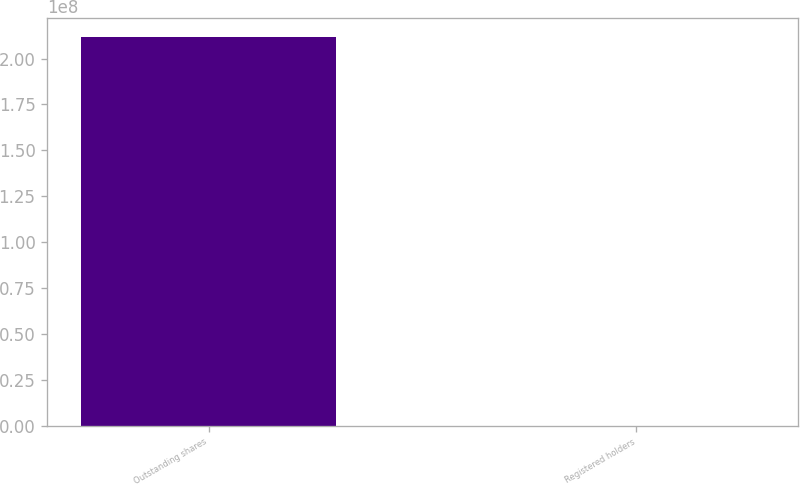Convert chart. <chart><loc_0><loc_0><loc_500><loc_500><bar_chart><fcel>Outstanding shares<fcel>Registered holders<nl><fcel>2.1171e+08<fcel>805<nl></chart> 